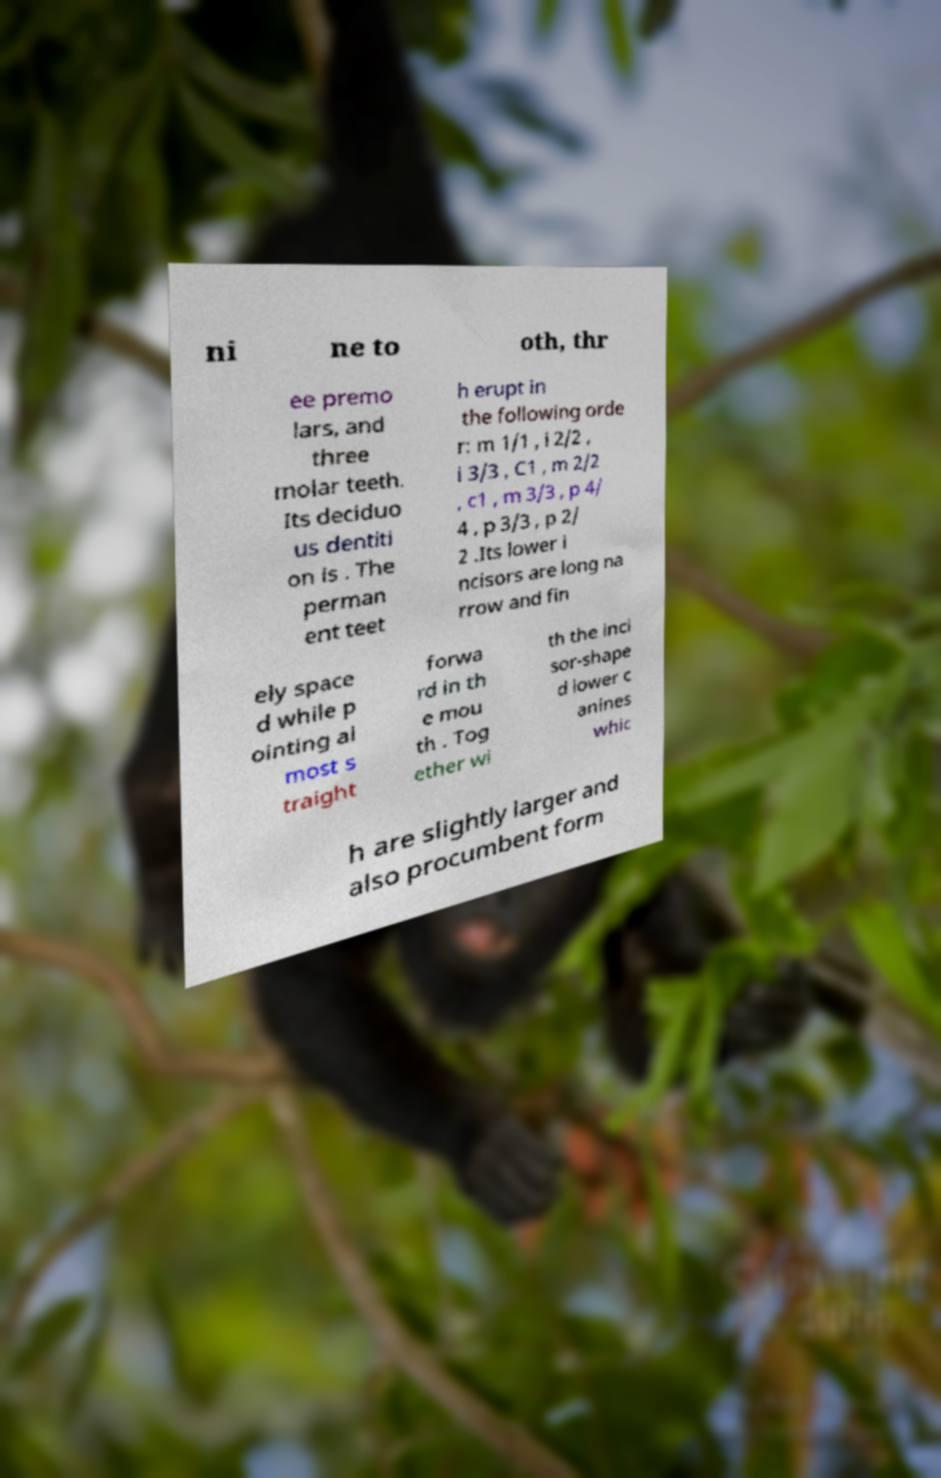Can you accurately transcribe the text from the provided image for me? ni ne to oth, thr ee premo lars, and three molar teeth. Its deciduo us dentiti on is . The perman ent teet h erupt in the following orde r: m 1/1 , i 2/2 , i 3/3 , C1 , m 2/2 , c1 , m 3/3 , p 4/ 4 , p 3/3 , p 2/ 2 .Its lower i ncisors are long na rrow and fin ely space d while p ointing al most s traight forwa rd in th e mou th . Tog ether wi th the inci sor-shape d lower c anines whic h are slightly larger and also procumbent form 